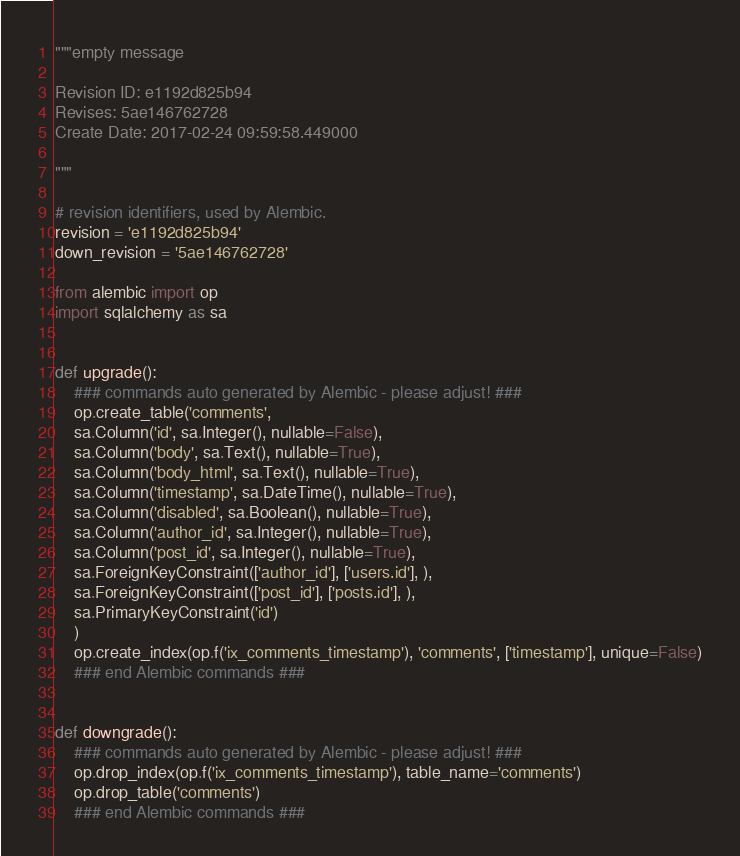Convert code to text. <code><loc_0><loc_0><loc_500><loc_500><_Python_>"""empty message

Revision ID: e1192d825b94
Revises: 5ae146762728
Create Date: 2017-02-24 09:59:58.449000

"""

# revision identifiers, used by Alembic.
revision = 'e1192d825b94'
down_revision = '5ae146762728'

from alembic import op
import sqlalchemy as sa


def upgrade():
    ### commands auto generated by Alembic - please adjust! ###
    op.create_table('comments',
    sa.Column('id', sa.Integer(), nullable=False),
    sa.Column('body', sa.Text(), nullable=True),
    sa.Column('body_html', sa.Text(), nullable=True),
    sa.Column('timestamp', sa.DateTime(), nullable=True),
    sa.Column('disabled', sa.Boolean(), nullable=True),
    sa.Column('author_id', sa.Integer(), nullable=True),
    sa.Column('post_id', sa.Integer(), nullable=True),
    sa.ForeignKeyConstraint(['author_id'], ['users.id'], ),
    sa.ForeignKeyConstraint(['post_id'], ['posts.id'], ),
    sa.PrimaryKeyConstraint('id')
    )
    op.create_index(op.f('ix_comments_timestamp'), 'comments', ['timestamp'], unique=False)
    ### end Alembic commands ###


def downgrade():
    ### commands auto generated by Alembic - please adjust! ###
    op.drop_index(op.f('ix_comments_timestamp'), table_name='comments')
    op.drop_table('comments')
    ### end Alembic commands ###
</code> 